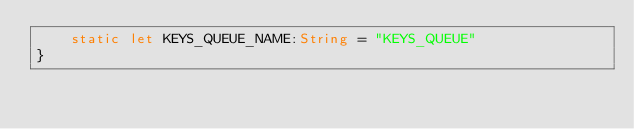<code> <loc_0><loc_0><loc_500><loc_500><_Swift_>    static let KEYS_QUEUE_NAME:String = "KEYS_QUEUE"
}

</code> 